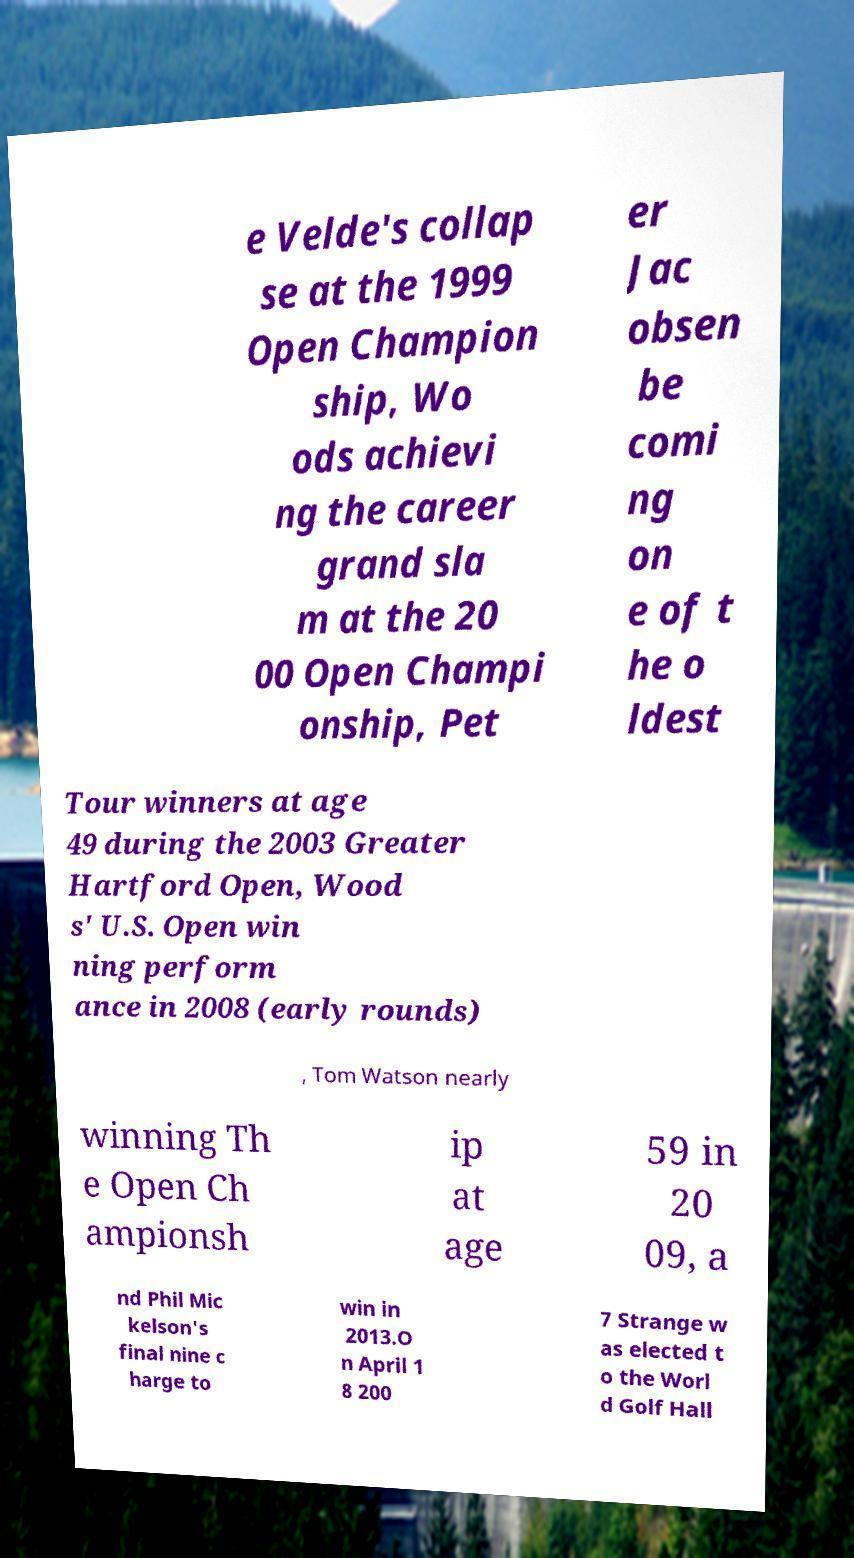Please identify and transcribe the text found in this image. e Velde's collap se at the 1999 Open Champion ship, Wo ods achievi ng the career grand sla m at the 20 00 Open Champi onship, Pet er Jac obsen be comi ng on e of t he o ldest Tour winners at age 49 during the 2003 Greater Hartford Open, Wood s' U.S. Open win ning perform ance in 2008 (early rounds) , Tom Watson nearly winning Th e Open Ch ampionsh ip at age 59 in 20 09, a nd Phil Mic kelson's final nine c harge to win in 2013.O n April 1 8 200 7 Strange w as elected t o the Worl d Golf Hall 